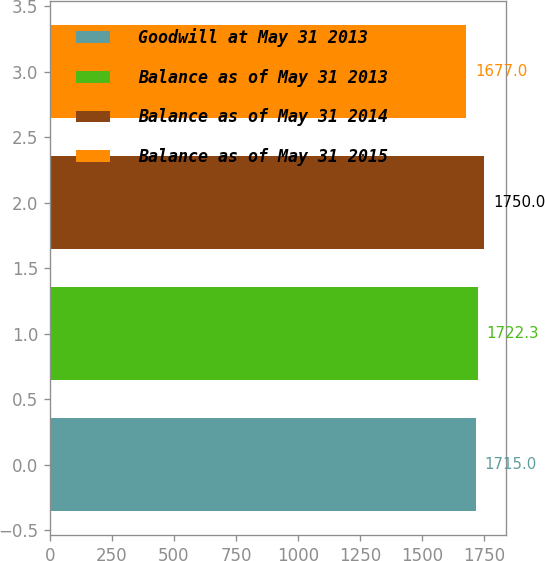Convert chart. <chart><loc_0><loc_0><loc_500><loc_500><bar_chart><fcel>Goodwill at May 31 2013<fcel>Balance as of May 31 2013<fcel>Balance as of May 31 2014<fcel>Balance as of May 31 2015<nl><fcel>1715<fcel>1722.3<fcel>1750<fcel>1677<nl></chart> 